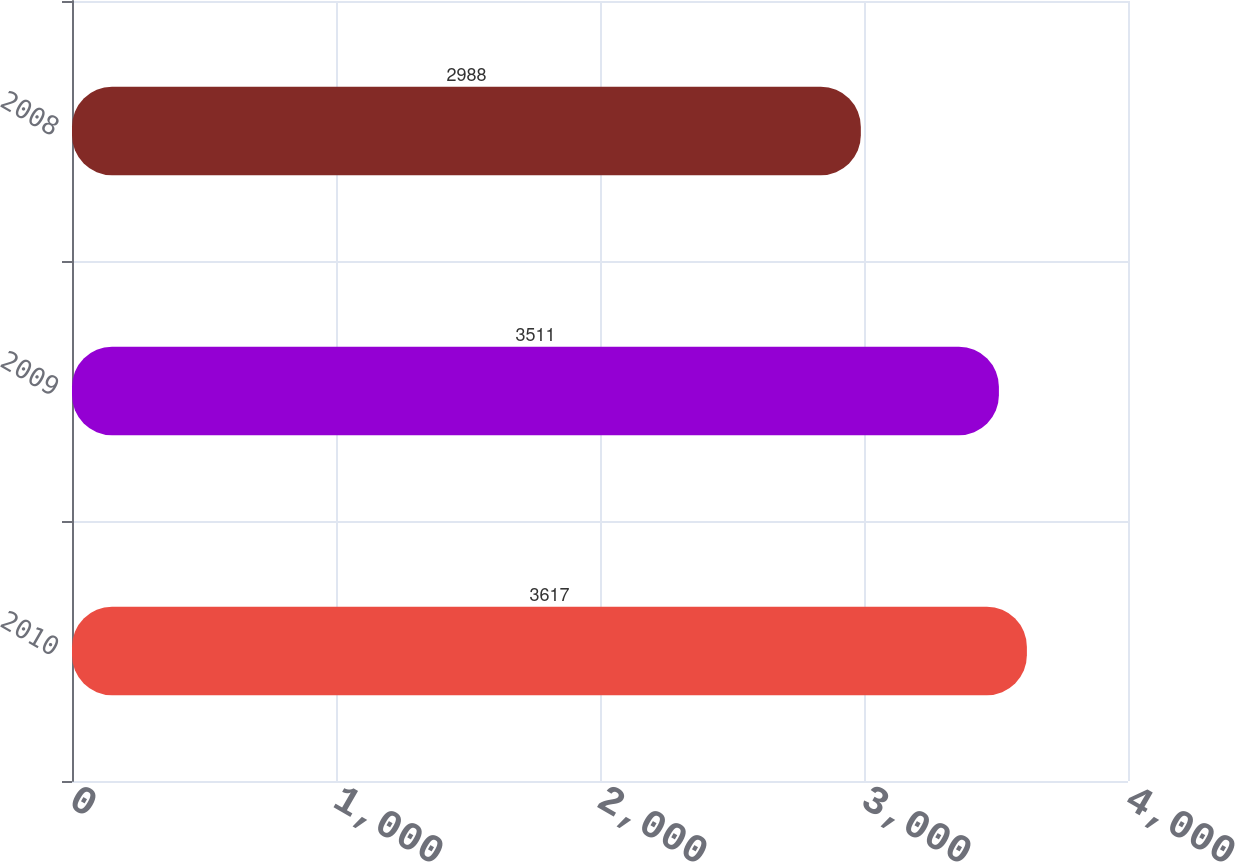Convert chart. <chart><loc_0><loc_0><loc_500><loc_500><bar_chart><fcel>2010<fcel>2009<fcel>2008<nl><fcel>3617<fcel>3511<fcel>2988<nl></chart> 